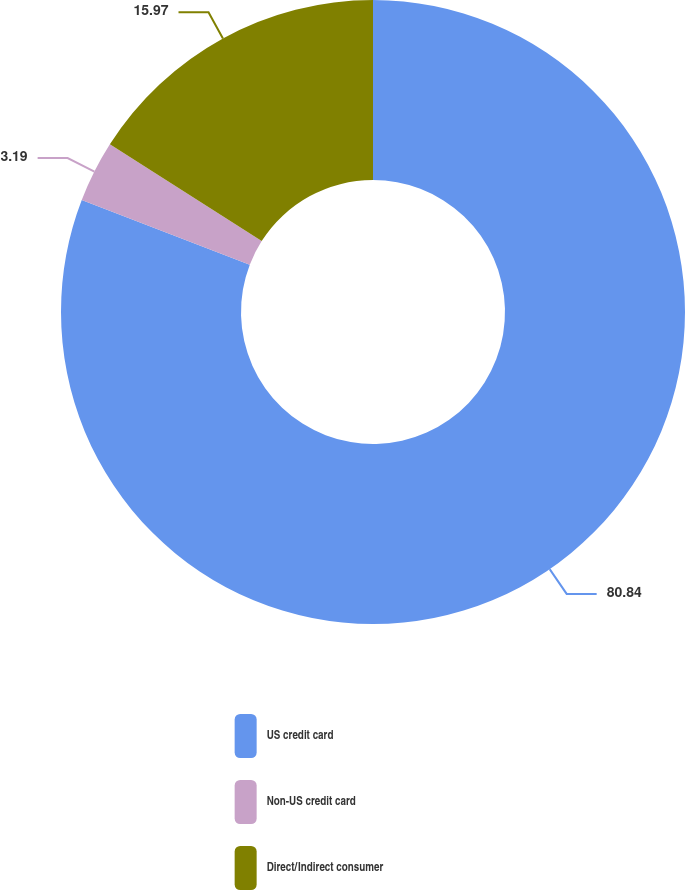Convert chart. <chart><loc_0><loc_0><loc_500><loc_500><pie_chart><fcel>US credit card<fcel>Non-US credit card<fcel>Direct/Indirect consumer<nl><fcel>80.83%<fcel>3.19%<fcel>15.97%<nl></chart> 